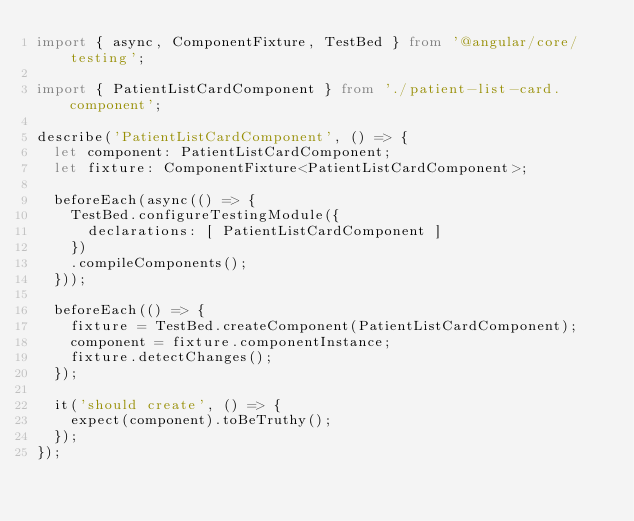<code> <loc_0><loc_0><loc_500><loc_500><_TypeScript_>import { async, ComponentFixture, TestBed } from '@angular/core/testing';

import { PatientListCardComponent } from './patient-list-card.component';

describe('PatientListCardComponent', () => {
  let component: PatientListCardComponent;
  let fixture: ComponentFixture<PatientListCardComponent>;

  beforeEach(async(() => {
    TestBed.configureTestingModule({
      declarations: [ PatientListCardComponent ]
    })
    .compileComponents();
  }));

  beforeEach(() => {
    fixture = TestBed.createComponent(PatientListCardComponent);
    component = fixture.componentInstance;
    fixture.detectChanges();
  });

  it('should create', () => {
    expect(component).toBeTruthy();
  });
});
</code> 